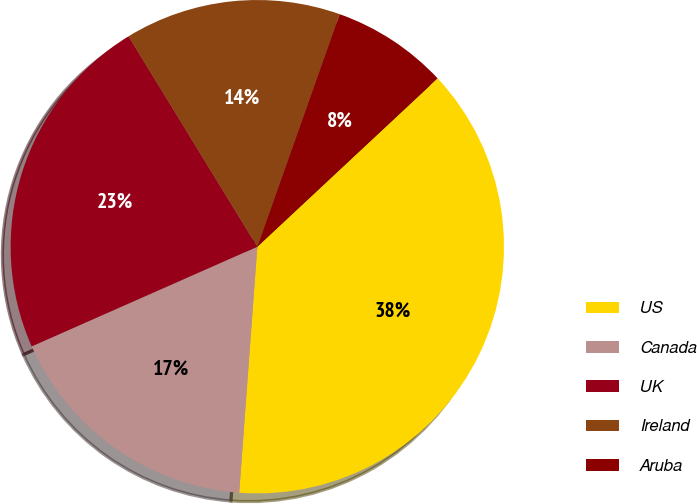Convert chart to OTSL. <chart><loc_0><loc_0><loc_500><loc_500><pie_chart><fcel>US<fcel>Canada<fcel>UK<fcel>Ireland<fcel>Aruba<nl><fcel>38.13%<fcel>17.21%<fcel>22.88%<fcel>14.16%<fcel>7.63%<nl></chart> 